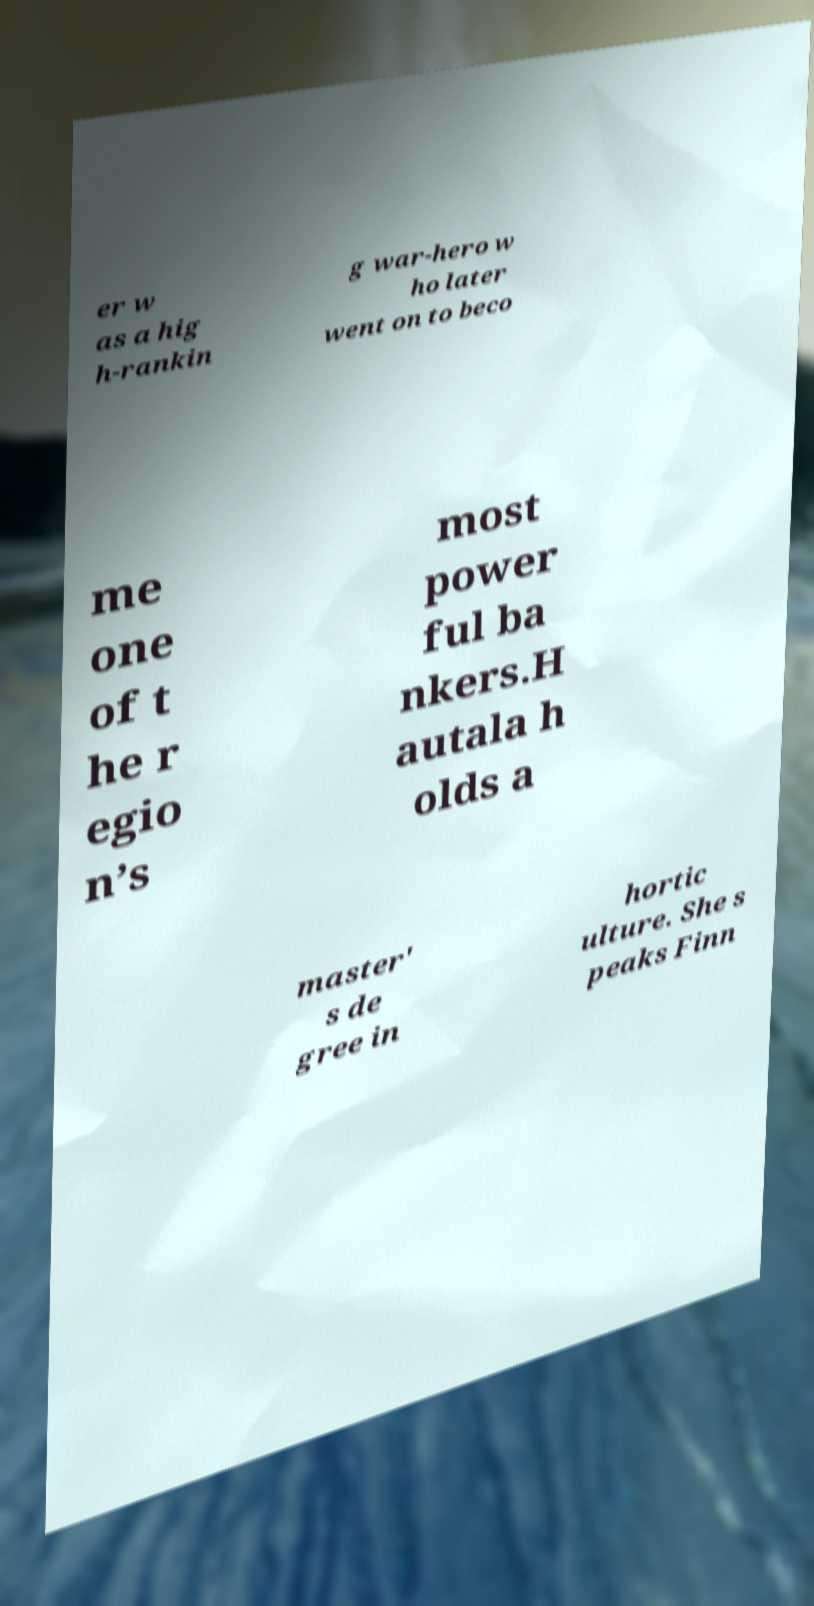There's text embedded in this image that I need extracted. Can you transcribe it verbatim? er w as a hig h-rankin g war-hero w ho later went on to beco me one of t he r egio n’s most power ful ba nkers.H autala h olds a master' s de gree in hortic ulture. She s peaks Finn 